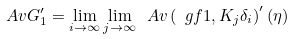Convert formula to latex. <formula><loc_0><loc_0><loc_500><loc_500>\ A v G _ { 1 } ^ { \prime } = \lim _ { i \to \infty } \lim _ { j \to \infty } \ A v \left ( \ g f { 1 , K _ { j } } { \delta _ { i } } \right ) ^ { \prime } ( \eta )</formula> 